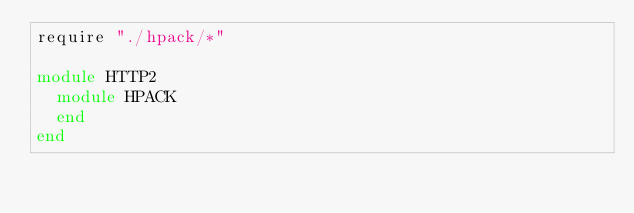Convert code to text. <code><loc_0><loc_0><loc_500><loc_500><_Crystal_>require "./hpack/*"

module HTTP2
  module HPACK
  end
end
</code> 